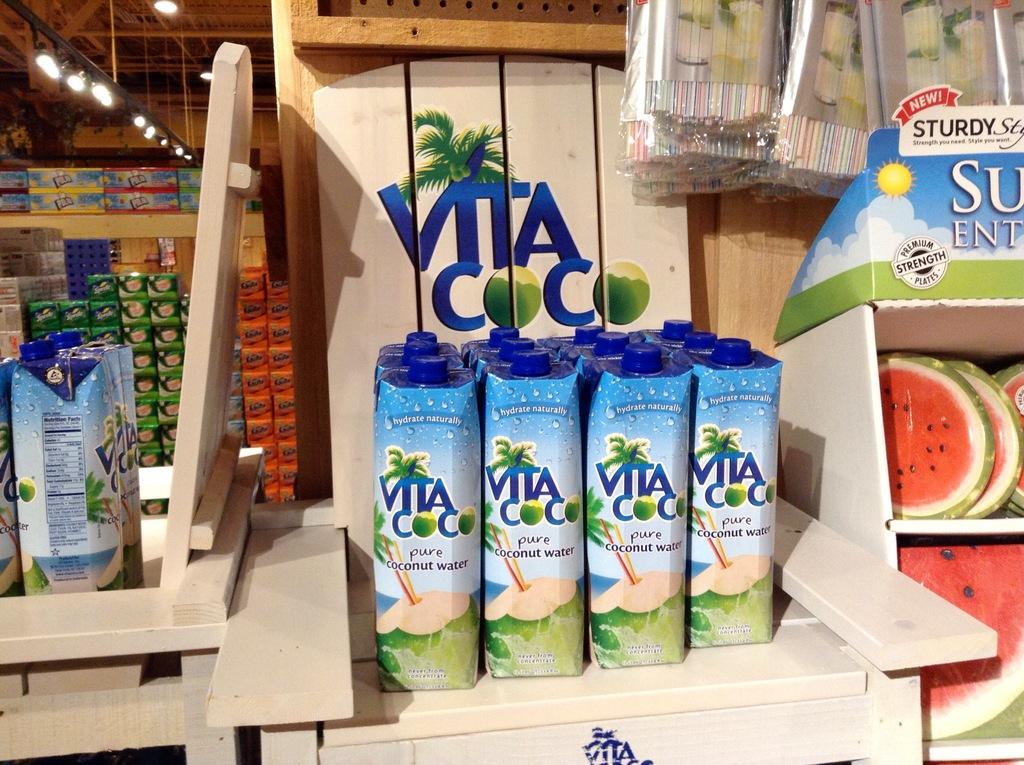What is the name of this drink?
Your answer should be very brief. Vita coco. 